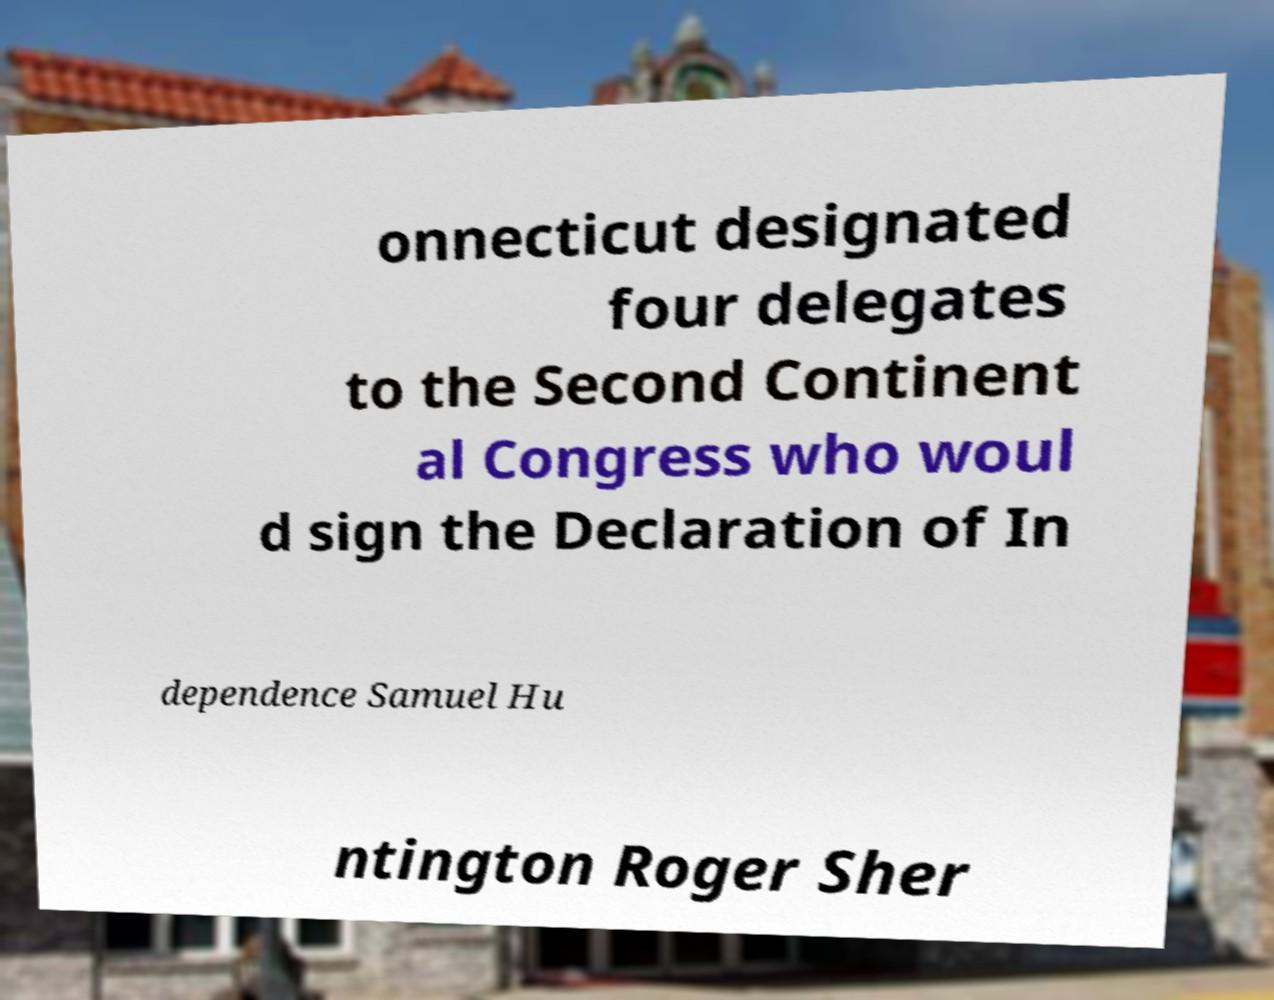For documentation purposes, I need the text within this image transcribed. Could you provide that? onnecticut designated four delegates to the Second Continent al Congress who woul d sign the Declaration of In dependence Samuel Hu ntington Roger Sher 